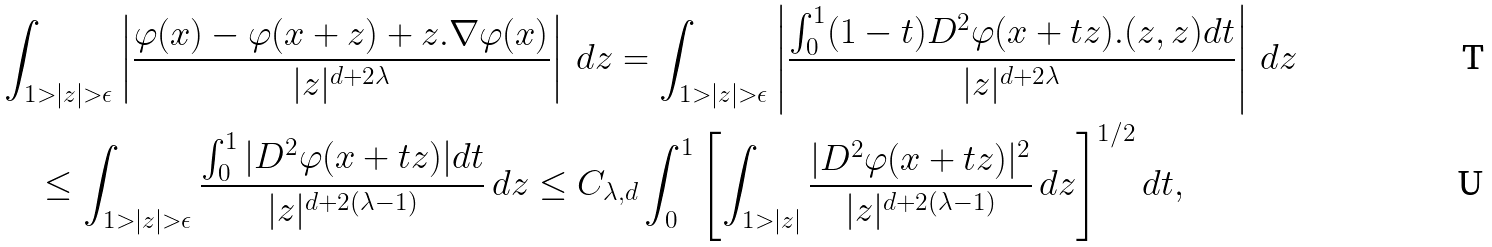<formula> <loc_0><loc_0><loc_500><loc_500>& \int _ { 1 > | z | > \epsilon } \left | \frac { \varphi ( x ) - \varphi ( x + z ) + z . \nabla \varphi ( x ) } { | z | ^ { d + 2 \lambda } } \right | \, d z = \int _ { 1 > | z | > \epsilon } \left | \frac { \int _ { 0 } ^ { 1 } ( 1 - t ) D ^ { 2 } \varphi ( x + t z ) . ( z , z ) d t } { | z | ^ { d + 2 \lambda } } \right | \, d z \\ & \quad \leq \int _ { 1 > | z | > \epsilon } \frac { \int _ { 0 } ^ { 1 } | D ^ { 2 } \varphi ( x + t z ) | d t } { | z | ^ { d + 2 ( \lambda - 1 ) } } \, d z \leq C _ { \lambda , d } \int _ { 0 } ^ { 1 } \left [ \int _ { 1 > | z | } \frac { | D ^ { 2 } \varphi ( x + t z ) | ^ { 2 } } { | z | ^ { d + 2 ( \lambda - 1 ) } } \, d z \right ] ^ { 1 / 2 } d t ,</formula> 